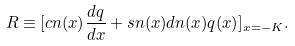Convert formula to latex. <formula><loc_0><loc_0><loc_500><loc_500>R \equiv [ c n ( x ) \frac { d q } { d x } + s n ( x ) d n ( x ) q ( x ) ] _ { x = - K } .</formula> 